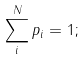Convert formula to latex. <formula><loc_0><loc_0><loc_500><loc_500>\sum _ { i } ^ { N } p _ { i } = 1 ;</formula> 